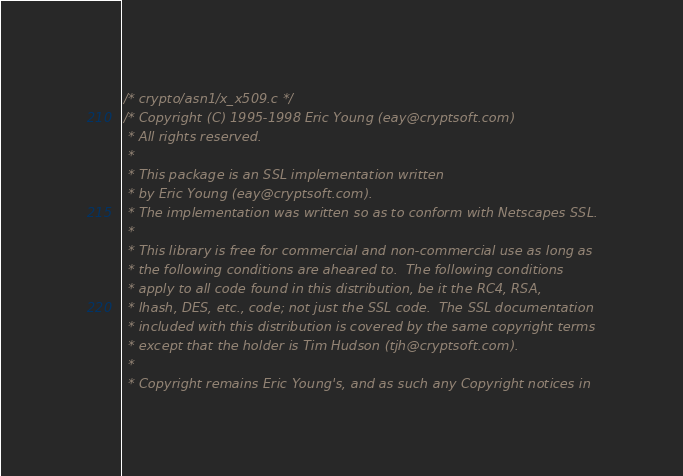Convert code to text. <code><loc_0><loc_0><loc_500><loc_500><_C_>/* crypto/asn1/x_x509.c */
/* Copyright (C) 1995-1998 Eric Young (eay@cryptsoft.com)
 * All rights reserved.
 *
 * This package is an SSL implementation written
 * by Eric Young (eay@cryptsoft.com).
 * The implementation was written so as to conform with Netscapes SSL.
 *
 * This library is free for commercial and non-commercial use as long as
 * the following conditions are aheared to.  The following conditions
 * apply to all code found in this distribution, be it the RC4, RSA,
 * lhash, DES, etc., code; not just the SSL code.  The SSL documentation
 * included with this distribution is covered by the same copyright terms
 * except that the holder is Tim Hudson (tjh@cryptsoft.com).
 *
 * Copyright remains Eric Young's, and as such any Copyright notices in</code> 